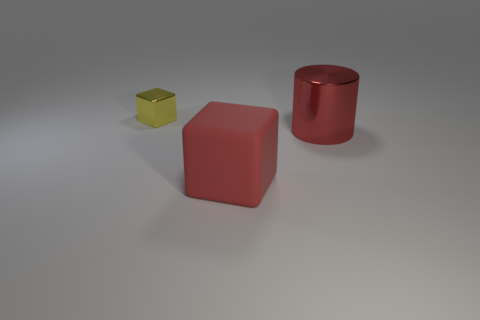Add 3 big red matte things. How many objects exist? 6 Subtract all blocks. How many objects are left? 1 Subtract 0 blue cylinders. How many objects are left? 3 Subtract all large red metallic cylinders. Subtract all shiny things. How many objects are left? 0 Add 2 tiny blocks. How many tiny blocks are left? 3 Add 2 red balls. How many red balls exist? 2 